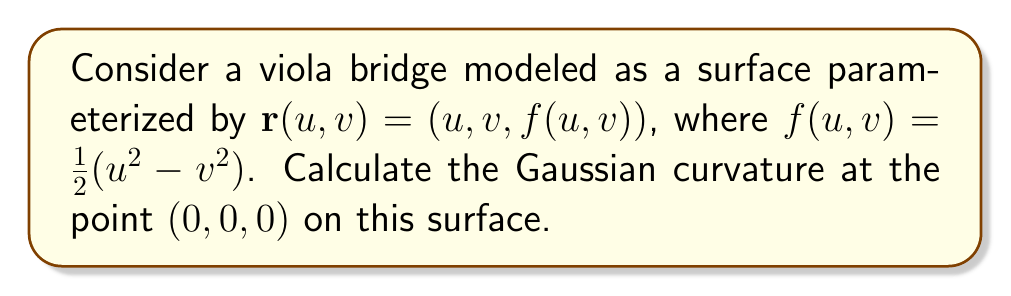Could you help me with this problem? To find the Gaussian curvature, we'll follow these steps:

1) First, we need to calculate the partial derivatives:
   $\mathbf{r}_u = (1, 0, u)$
   $\mathbf{r}_v = (0, 1, -v)$
   $\mathbf{r}_{uu} = (0, 0, 1)$
   $\mathbf{r}_{uv} = (0, 0, 0)$
   $\mathbf{r}_{vv} = (0, 0, -1)$

2) Next, we calculate the normal vector:
   $\mathbf{N} = \frac{\mathbf{r}_u \times \mathbf{r}_v}{|\mathbf{r}_u \times \mathbf{r}_v|}$
   $= \frac{(u, v, 1)}{\sqrt{1 + u^2 + v^2}}$

3) Now we can calculate the coefficients of the first fundamental form:
   $E = \mathbf{r}_u \cdot \mathbf{r}_u = 1 + u^2$
   $F = \mathbf{r}_u \cdot \mathbf{r}_v = 0$
   $G = \mathbf{r}_v \cdot \mathbf{r}_v = 1 + v^2$

4) And the coefficients of the second fundamental form:
   $e = \mathbf{r}_{uu} \cdot \mathbf{N} = \frac{1}{\sqrt{1 + u^2 + v^2}}$
   $f = \mathbf{r}_{uv} \cdot \mathbf{N} = 0$
   $g = \mathbf{r}_{vv} \cdot \mathbf{N} = \frac{-1}{\sqrt{1 + u^2 + v^2}}$

5) The Gaussian curvature is given by:
   $K = \frac{eg - f^2}{EG - F^2}$

6) Substituting the values at (0,0,0):
   $K = \frac{(1)((-1)) - 0^2}{(1)(1) - 0^2} = -1$

Therefore, the Gaussian curvature at (0,0,0) is -1.
Answer: $-1$ 